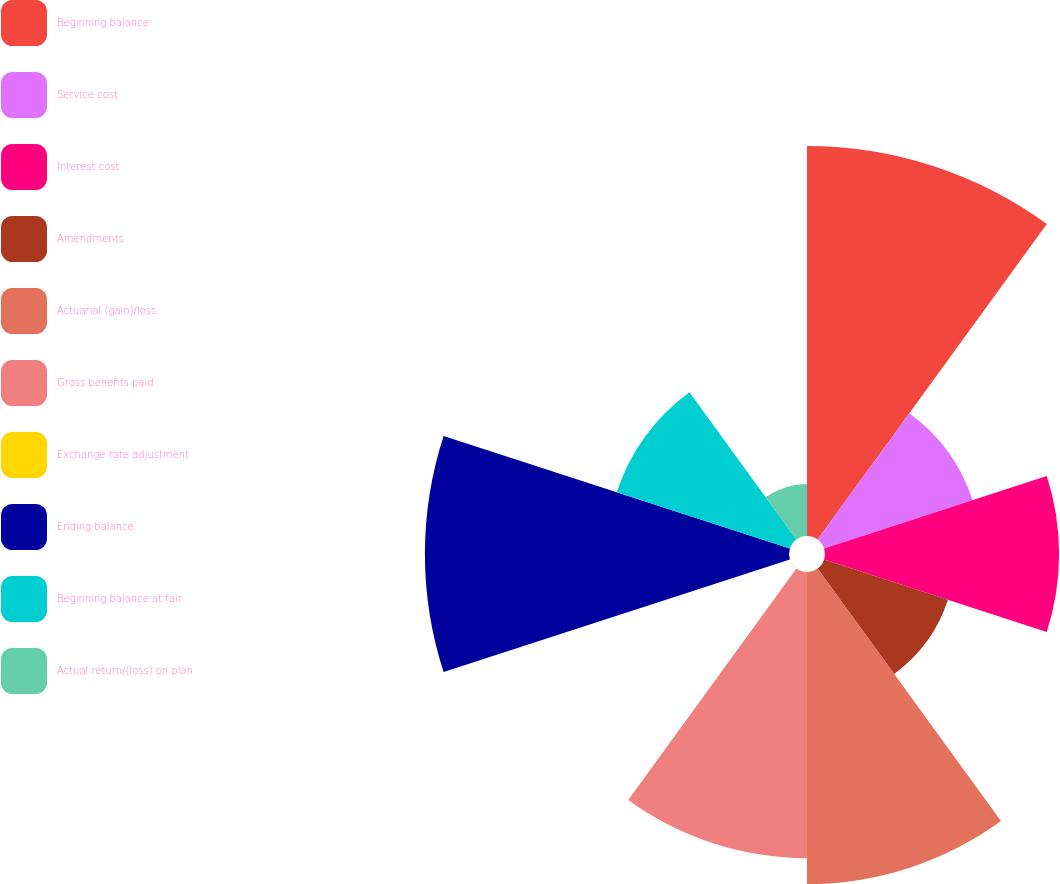<chart> <loc_0><loc_0><loc_500><loc_500><pie_chart><fcel>Beginning balance<fcel>Service cost<fcel>Interest cost<fcel>Amendments<fcel>Actuarial (gain)/loss<fcel>Gross benefits paid<fcel>Exchange rate adjustment<fcel>Ending balance<fcel>Beginning balance at fair<fcel>Actual return/(loss) on plan<nl><fcel>18.51%<fcel>7.41%<fcel>11.11%<fcel>6.18%<fcel>14.81%<fcel>13.58%<fcel>0.01%<fcel>17.28%<fcel>8.64%<fcel>2.47%<nl></chart> 